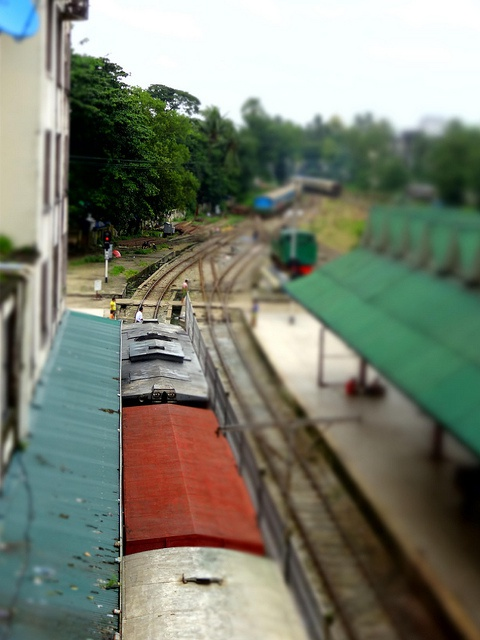Describe the objects in this image and their specific colors. I can see train in lightblue, brown, darkgray, and beige tones, train in lightblue, gray, darkgray, teal, and black tones, train in lightblue, gray, and black tones, people in lightblue, lavender, darkgray, black, and gray tones, and traffic light in lightblue, black, maroon, and red tones in this image. 